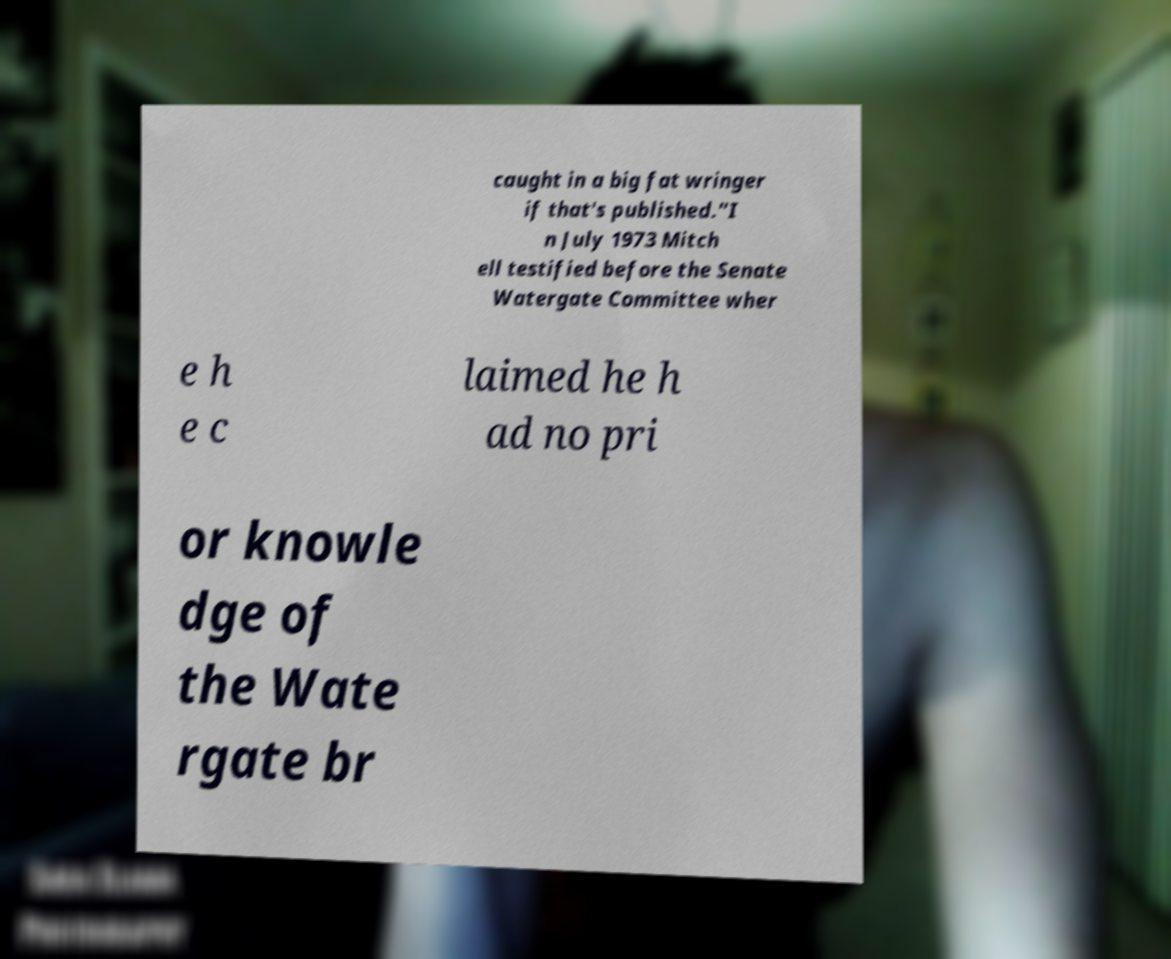For documentation purposes, I need the text within this image transcribed. Could you provide that? caught in a big fat wringer if that's published."I n July 1973 Mitch ell testified before the Senate Watergate Committee wher e h e c laimed he h ad no pri or knowle dge of the Wate rgate br 